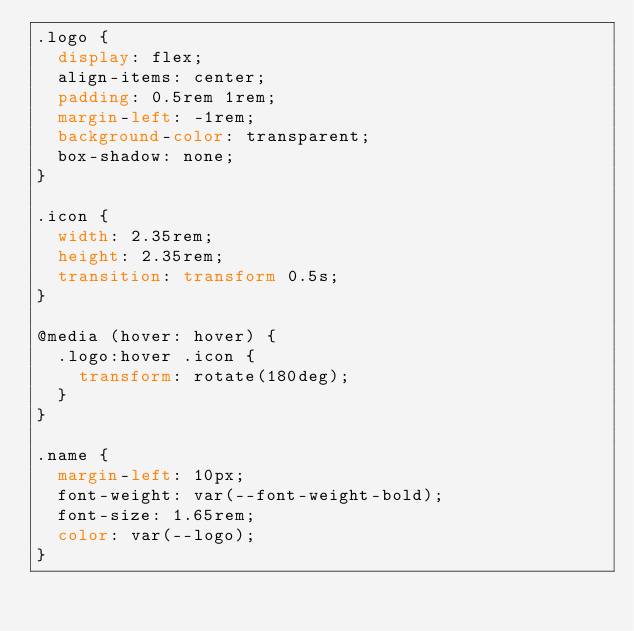Convert code to text. <code><loc_0><loc_0><loc_500><loc_500><_CSS_>.logo {
  display: flex;
  align-items: center;
  padding: 0.5rem 1rem;
  margin-left: -1rem;
  background-color: transparent;
  box-shadow: none;
}

.icon {
  width: 2.35rem;
  height: 2.35rem;
  transition: transform 0.5s;
}

@media (hover: hover) {
  .logo:hover .icon {
    transform: rotate(180deg);
  }
}

.name {
  margin-left: 10px;
  font-weight: var(--font-weight-bold);
  font-size: 1.65rem;
  color: var(--logo);
}
</code> 